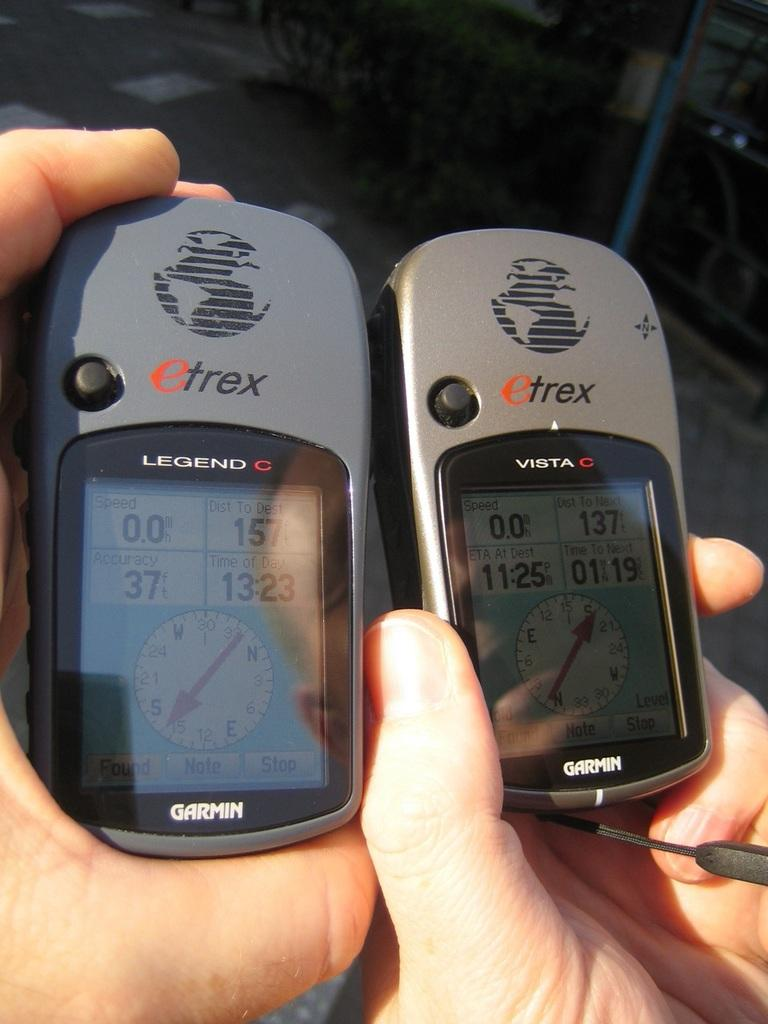<image>
Share a concise interpretation of the image provided. Two Garmin devices have an etrex logo on them also. 